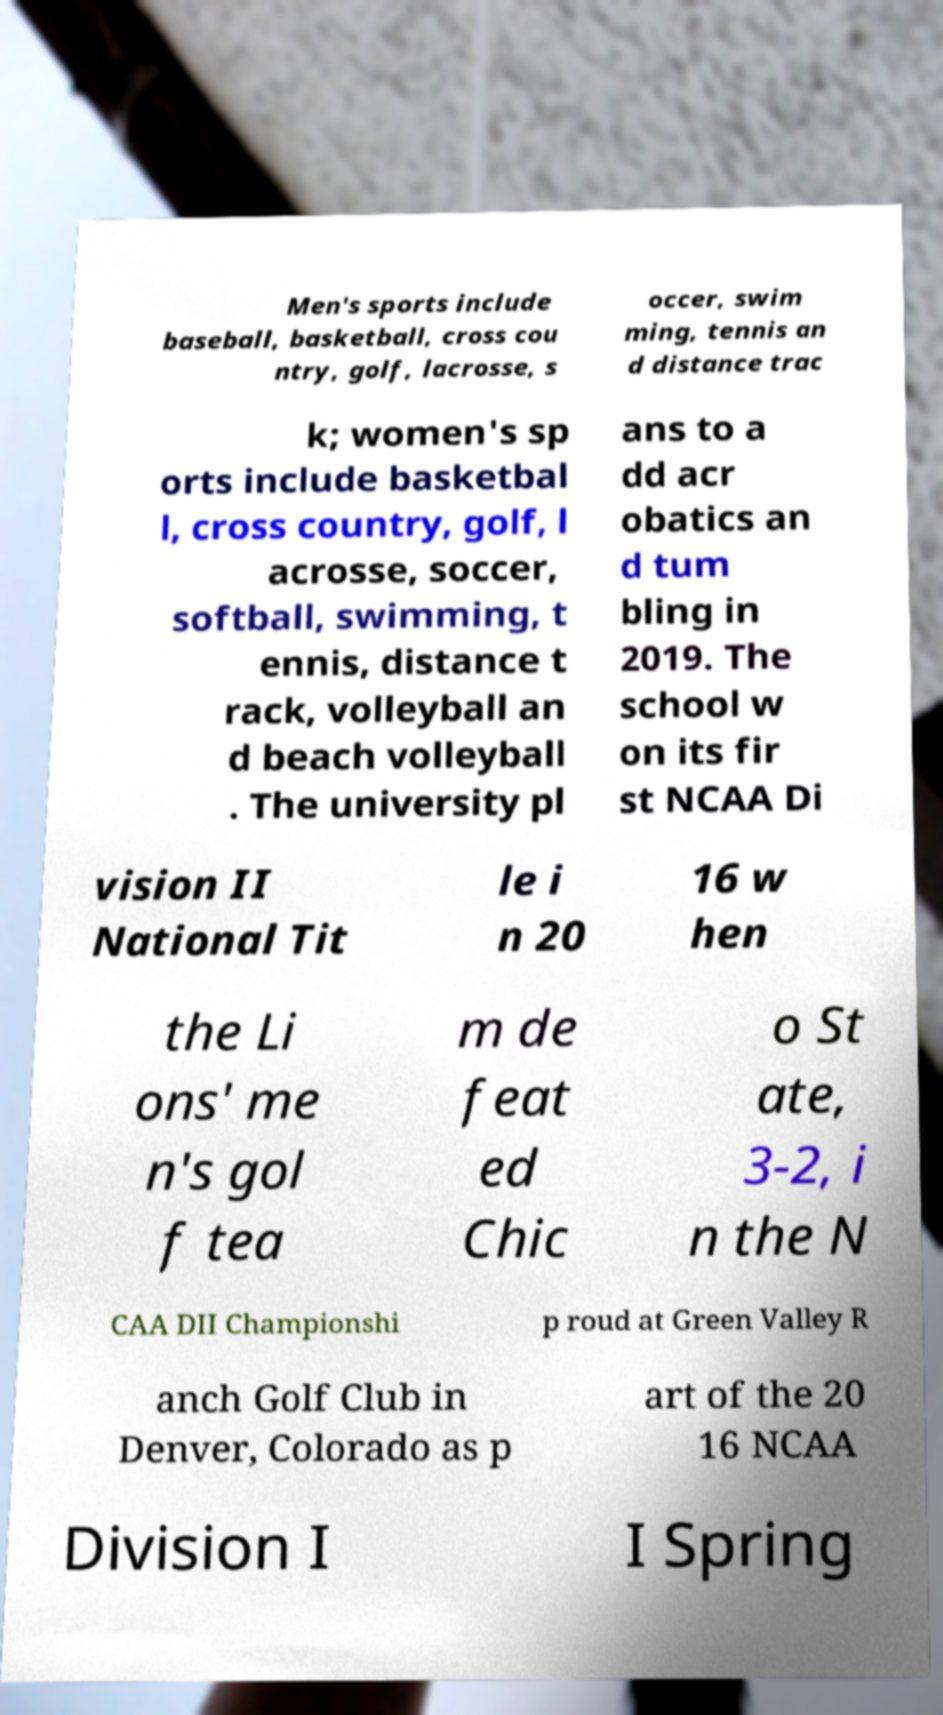Please read and relay the text visible in this image. What does it say? Men's sports include baseball, basketball, cross cou ntry, golf, lacrosse, s occer, swim ming, tennis an d distance trac k; women's sp orts include basketbal l, cross country, golf, l acrosse, soccer, softball, swimming, t ennis, distance t rack, volleyball an d beach volleyball . The university pl ans to a dd acr obatics an d tum bling in 2019. The school w on its fir st NCAA Di vision II National Tit le i n 20 16 w hen the Li ons' me n's gol f tea m de feat ed Chic o St ate, 3-2, i n the N CAA DII Championshi p roud at Green Valley R anch Golf Club in Denver, Colorado as p art of the 20 16 NCAA Division I I Spring 